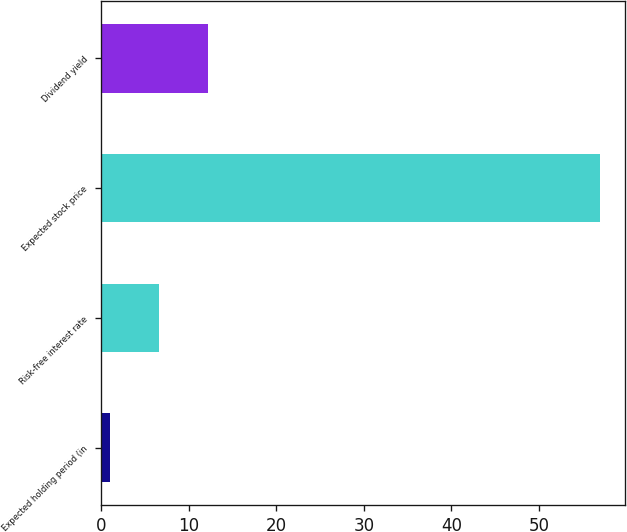Convert chart. <chart><loc_0><loc_0><loc_500><loc_500><bar_chart><fcel>Expected holding period (in<fcel>Risk-free interest rate<fcel>Expected stock price<fcel>Dividend yield<nl><fcel>1<fcel>6.6<fcel>57<fcel>12.2<nl></chart> 